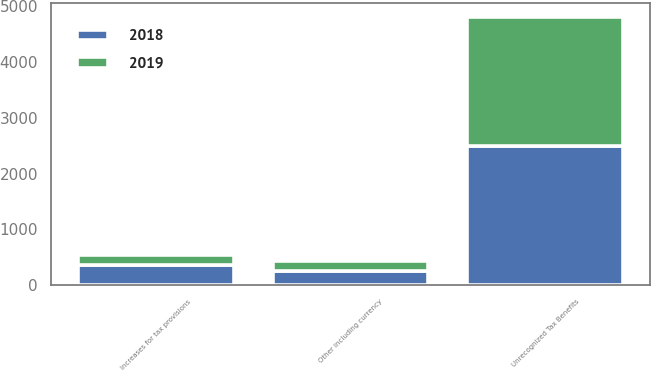<chart> <loc_0><loc_0><loc_500><loc_500><stacked_bar_chart><ecel><fcel>Unrecognized Tax Benefits<fcel>Increases for tax provisions<fcel>Other including currency<nl><fcel>2019<fcel>2314<fcel>178<fcel>178<nl><fcel>2018<fcel>2500<fcel>356<fcel>260<nl></chart> 